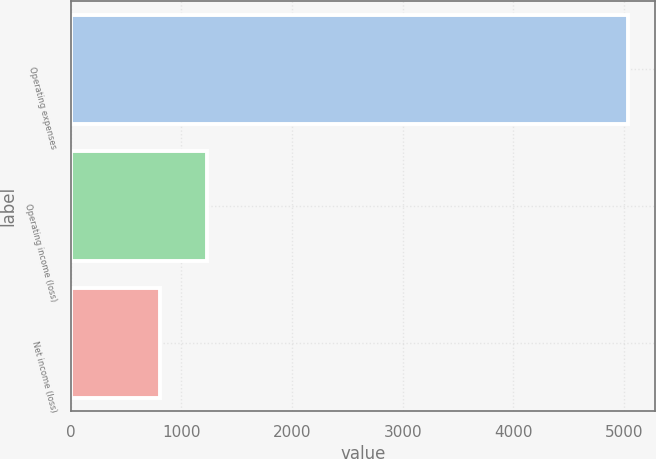<chart> <loc_0><loc_0><loc_500><loc_500><bar_chart><fcel>Operating expenses<fcel>Operating income (loss)<fcel>Net income (loss)<nl><fcel>5031<fcel>1232<fcel>804<nl></chart> 